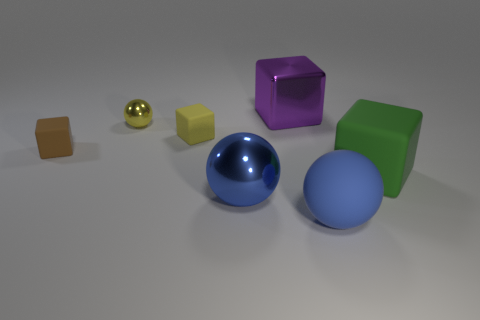How many yellow blocks are in front of the yellow object that is on the right side of the metal sphere that is behind the green rubber cube?
Your answer should be very brief. 0. There is a large matte thing behind the large matte sphere; is it the same shape as the brown matte object?
Give a very brief answer. Yes. How many things are yellow metallic cylinders or large things that are to the left of the green matte thing?
Provide a short and direct response. 3. Are there more small yellow things that are right of the tiny yellow sphere than large cylinders?
Offer a terse response. Yes. Are there an equal number of big purple things that are in front of the purple metal object and purple metal blocks on the right side of the green matte thing?
Give a very brief answer. Yes. Are there any big green matte things that are on the right side of the metallic ball behind the big matte cube?
Your answer should be compact. Yes. What shape is the brown object?
Make the answer very short. Cube. There is a rubber thing that is the same color as the big metallic sphere; what size is it?
Offer a terse response. Large. What size is the shiny ball that is behind the tiny block that is on the left side of the tiny yellow matte object?
Keep it short and to the point. Small. What size is the metallic thing in front of the tiny yellow rubber object?
Offer a terse response. Large. 